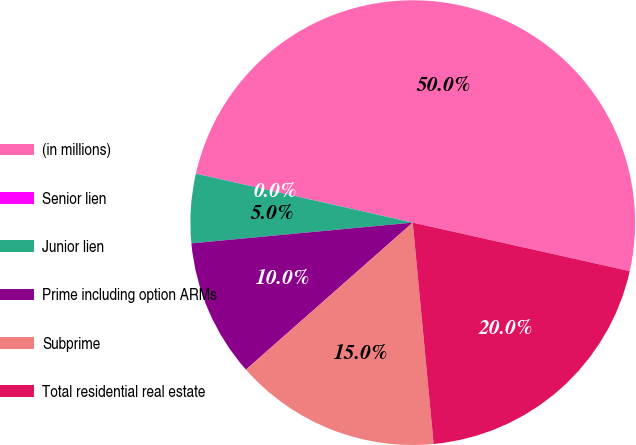Convert chart. <chart><loc_0><loc_0><loc_500><loc_500><pie_chart><fcel>(in millions)<fcel>Senior lien<fcel>Junior lien<fcel>Prime including option ARMs<fcel>Subprime<fcel>Total residential real estate<nl><fcel>49.95%<fcel>0.02%<fcel>5.02%<fcel>10.01%<fcel>15.0%<fcel>20.0%<nl></chart> 